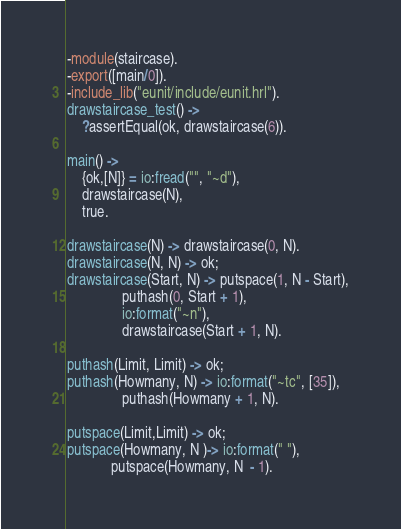<code> <loc_0><loc_0><loc_500><loc_500><_Erlang_>-module(staircase).
-export([main/0]).
-include_lib("eunit/include/eunit.hrl").
drawstaircase_test() ->
    ?assertEqual(ok, drawstaircase(6)).

main() ->
    {ok,[N]} = io:fread("", "~d"),
    drawstaircase(N),
    true.

drawstaircase(N) -> drawstaircase(0, N).
drawstaircase(N, N) -> ok;
drawstaircase(Start, N) -> putspace(1, N - Start),
			   puthash(0, Start + 1),
			   io:format("~n"),
			   drawstaircase(Start + 1, N).

puthash(Limit, Limit) -> ok;
puthash(Howmany, N) -> io:format("~tc", [35]),
		       puthash(Howmany + 1, N).

putspace(Limit,Limit) -> ok;
putspace(Howmany, N )-> io:format(" "),
			putspace(Howmany, N  - 1).
</code> 